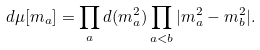<formula> <loc_0><loc_0><loc_500><loc_500>d \mu [ m _ { a } ] = \prod _ { a } d ( m _ { a } ^ { 2 } ) \prod _ { a < b } | m _ { a } ^ { 2 } - m _ { b } ^ { 2 } | .</formula> 